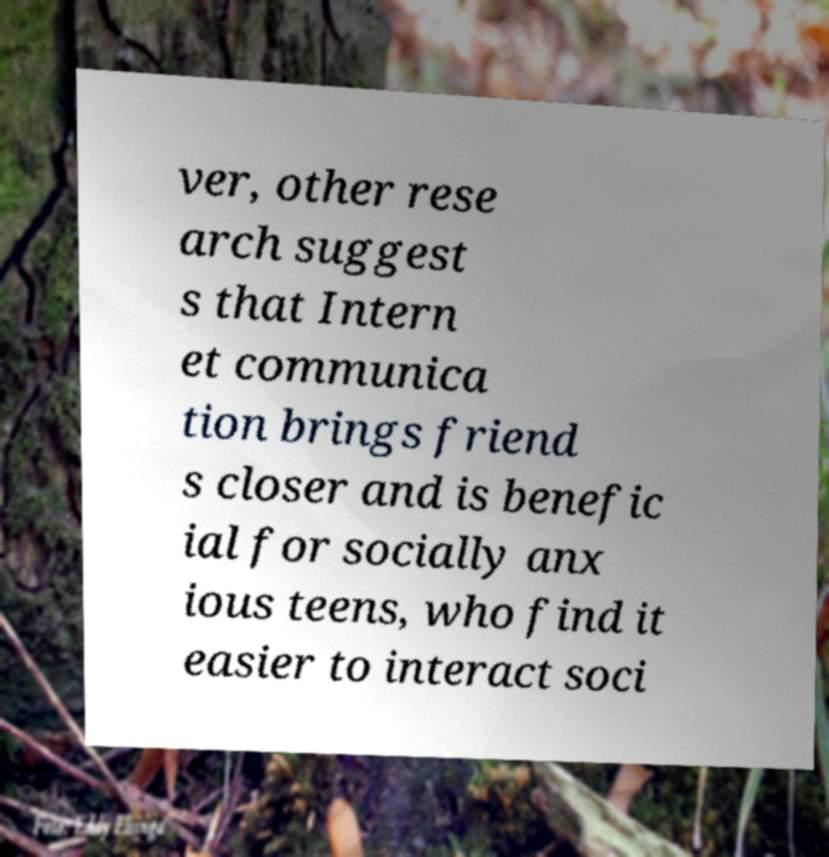Can you accurately transcribe the text from the provided image for me? ver, other rese arch suggest s that Intern et communica tion brings friend s closer and is benefic ial for socially anx ious teens, who find it easier to interact soci 